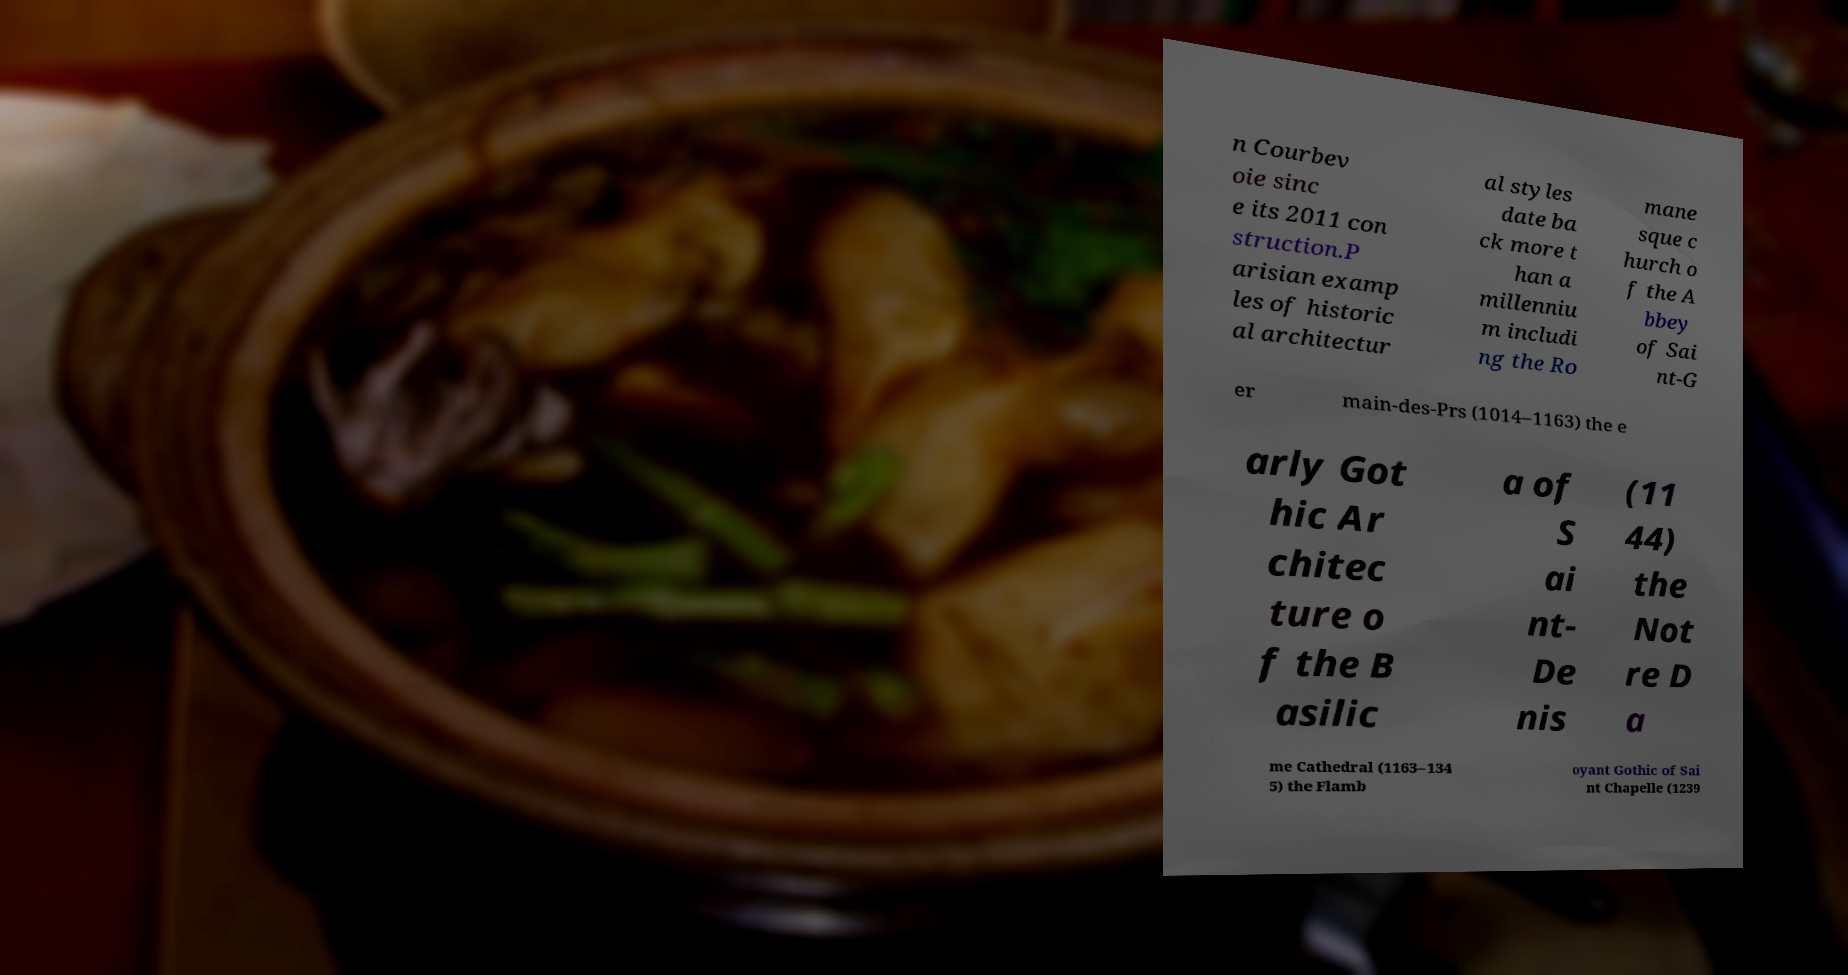I need the written content from this picture converted into text. Can you do that? n Courbev oie sinc e its 2011 con struction.P arisian examp les of historic al architectur al styles date ba ck more t han a millenniu m includi ng the Ro mane sque c hurch o f the A bbey of Sai nt-G er main-des-Prs (1014–1163) the e arly Got hic Ar chitec ture o f the B asilic a of S ai nt- De nis (11 44) the Not re D a me Cathedral (1163–134 5) the Flamb oyant Gothic of Sai nt Chapelle (1239 